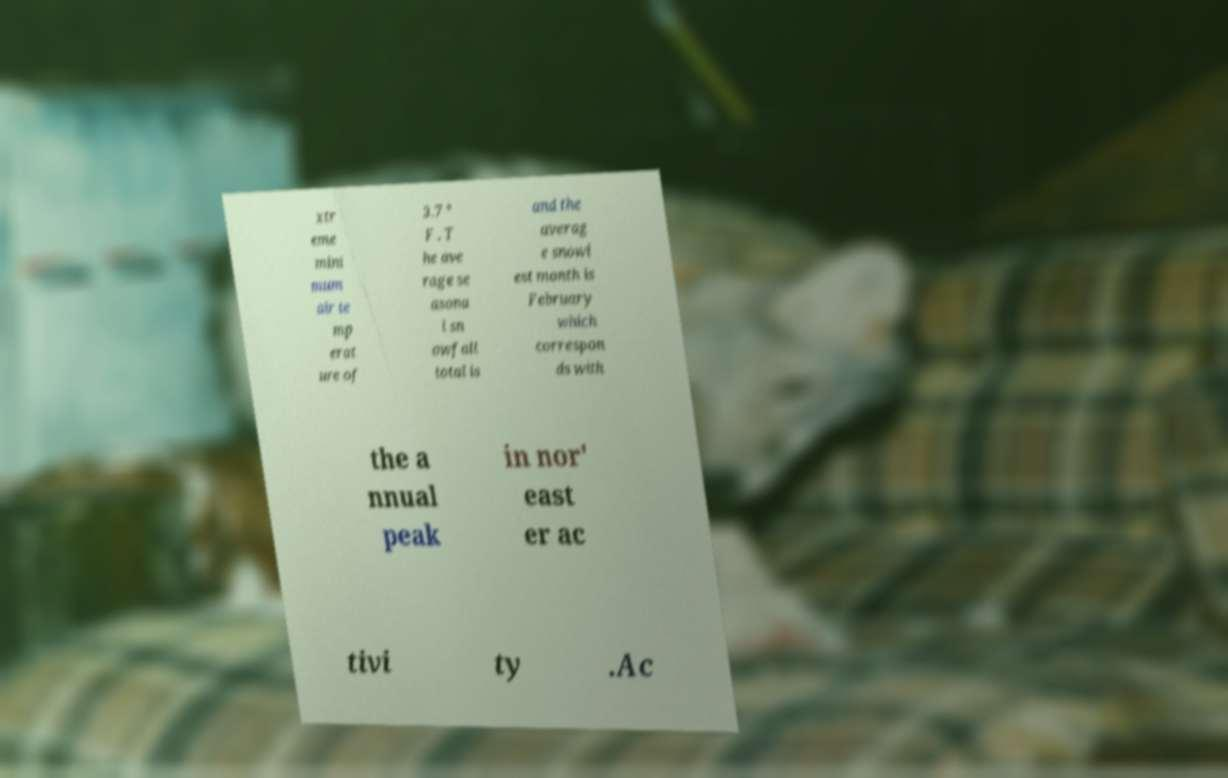Please identify and transcribe the text found in this image. xtr eme mini mum air te mp erat ure of 3.7 ° F . T he ave rage se asona l sn owfall total is and the averag e snowi est month is February which correspon ds with the a nnual peak in nor' east er ac tivi ty .Ac 